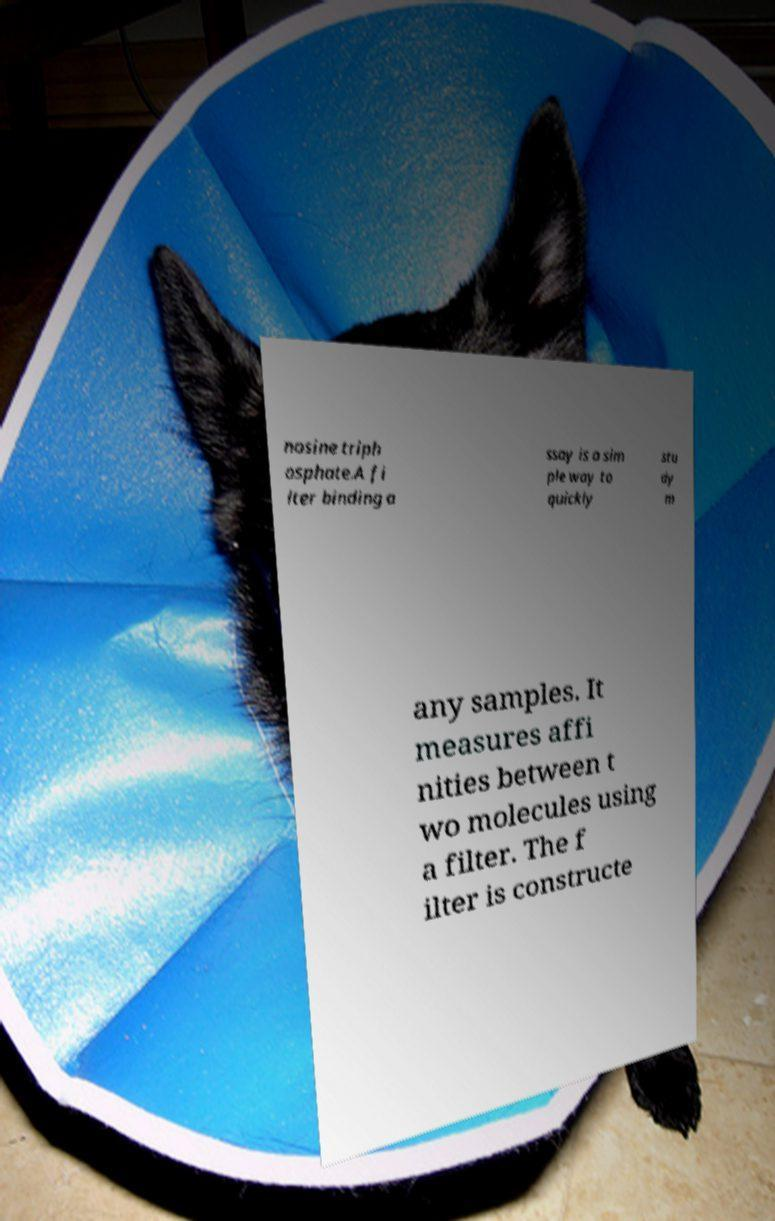I need the written content from this picture converted into text. Can you do that? nosine triph osphate.A fi lter binding a ssay is a sim ple way to quickly stu dy m any samples. It measures affi nities between t wo molecules using a filter. The f ilter is constructe 